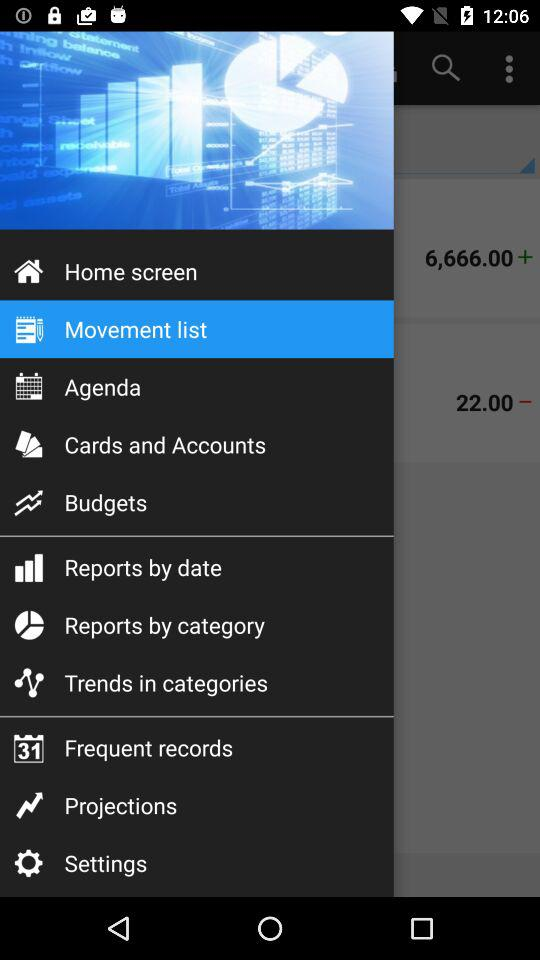Which item has been selected in the menu? The selected item in the menu is "Movement list". 